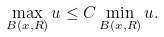Convert formula to latex. <formula><loc_0><loc_0><loc_500><loc_500>\max _ { B ( x , R ) } u \leq C \min _ { B ( x , R ) } u .</formula> 